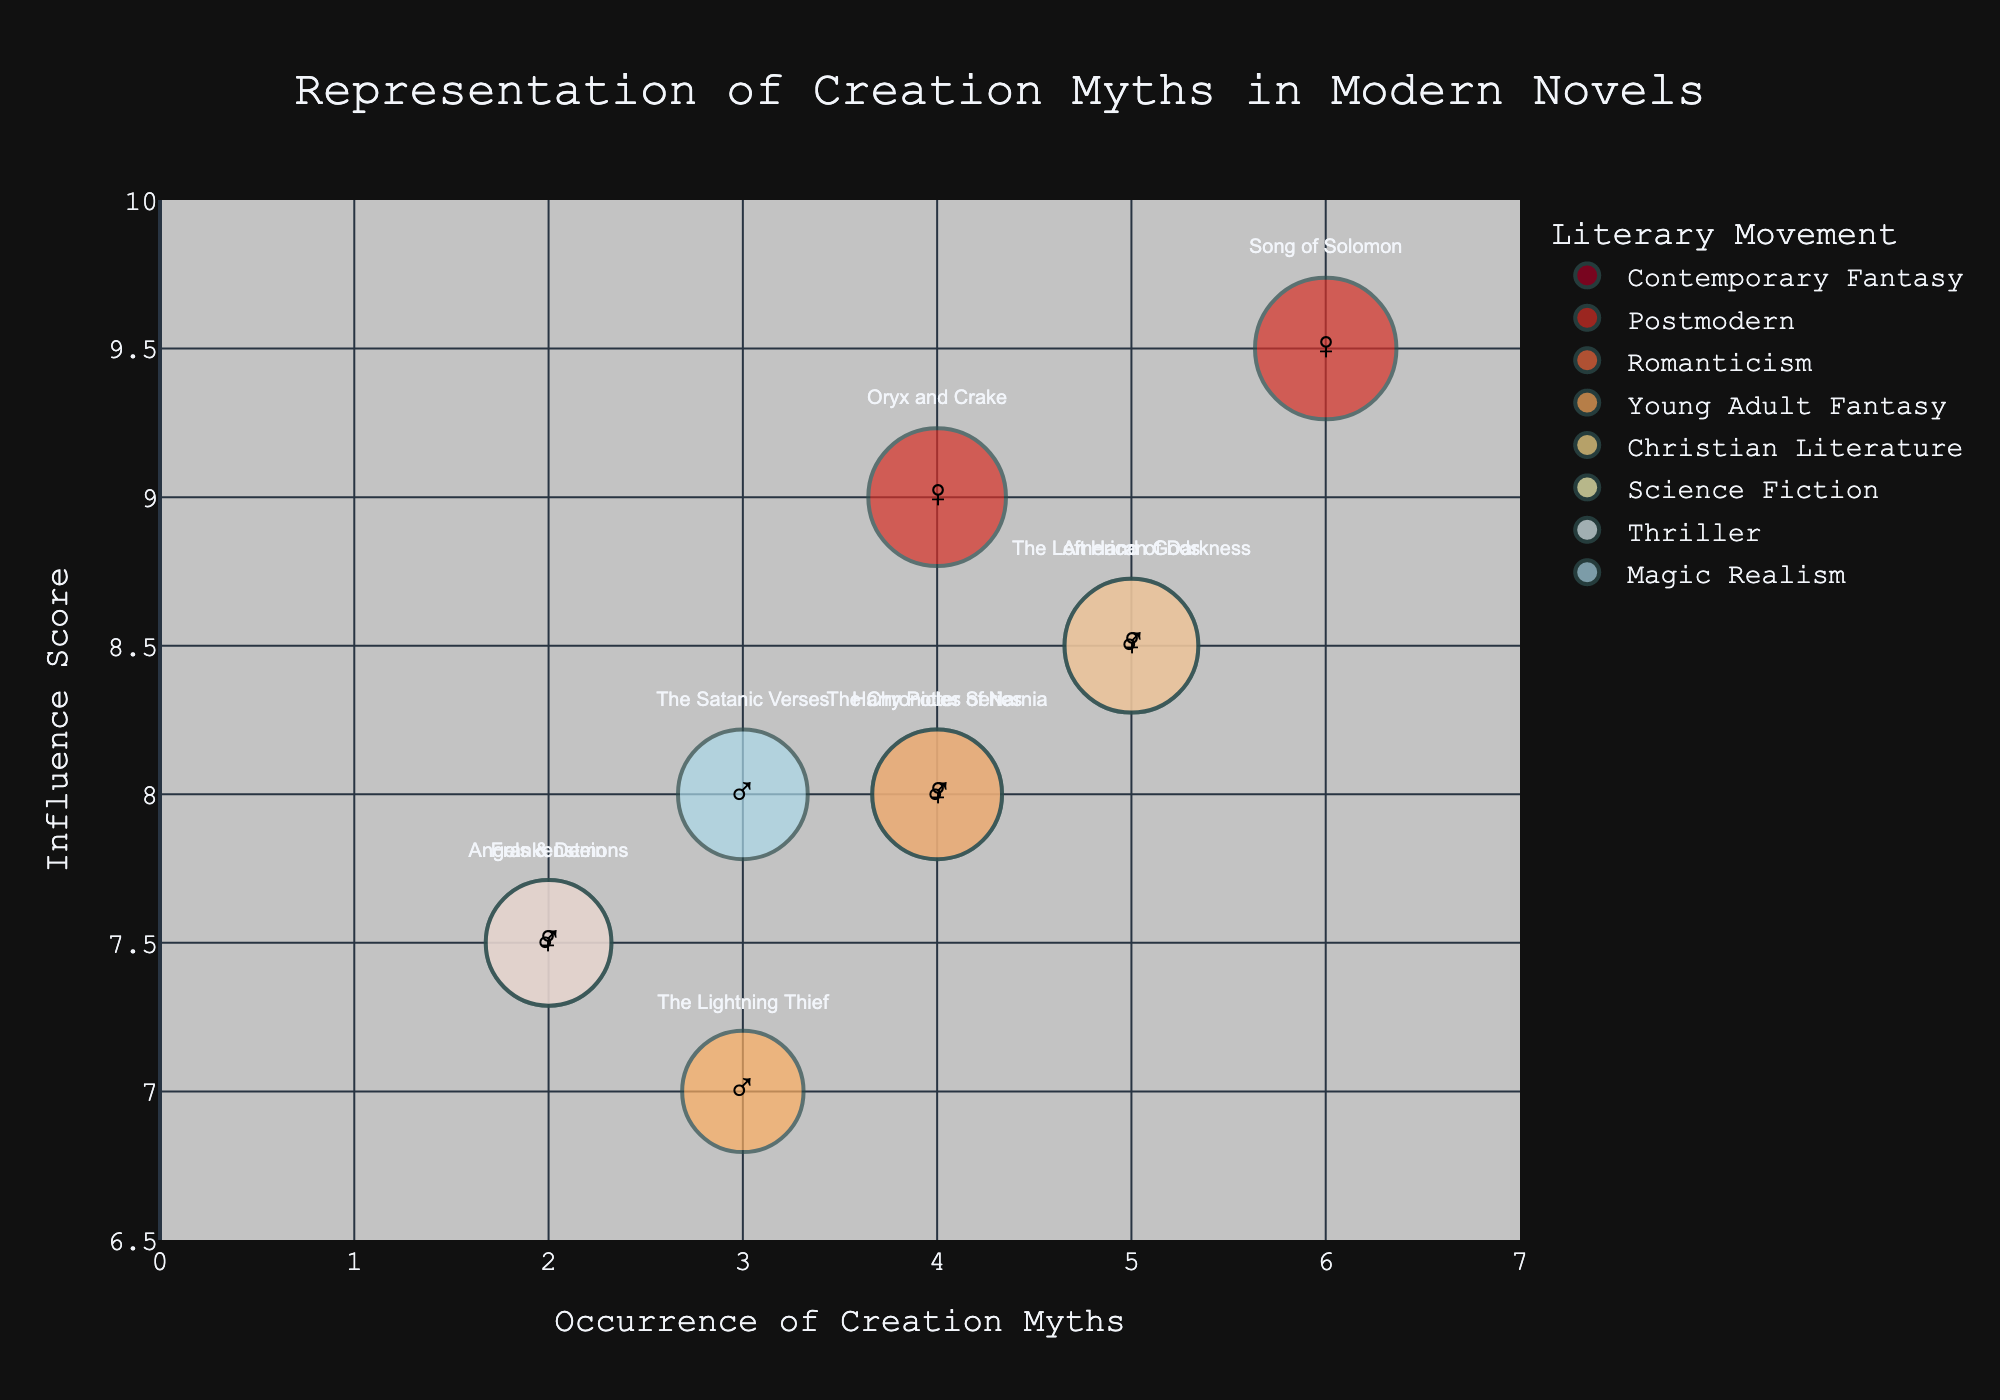What is the title of the chart? The title is prominently displayed at the top of the chart and reads "Representation of Creation Myths in Modern Novels".
Answer: Representation of Creation Myths in Modern Novels How many authors are represented in the chart? By counting the unique data points (bubbles) on the chart, each corresponding to an author, we find there are 10 authors represented.
Answer: 10 Which author has the highest Influence Score and what is it? By looking at the y-axis where Influence Score is plotted, we observe Toni Morrison’s bubble is positioned highest at 9.5.
Answer: Toni Morrison, 9.5 Which Literary Movement has the most occurrences of creation myths? By looking at the x-axis and comparing the bubbles' horizontal positions (Occurrence of Creation Myths), the Postmodern movement has Toni Morrison with 6 and Margaret Atwood with 4, totaling 10 occurrences, which is the highest.
Answer: Postmodern What is the Occurrence of Creation Myths for "The Chronicles of Narnia"? By hovering over or finding the bubble labeled "The Chronicles of Narnia" by C.S. Lewis, we see its position on the x-axis is at 4.
Answer: 4 Who is the male author in the Magic Realism movement and what are his Occurrence of Creation Myths and Influence Score? By identifying the male symbol (♂) and the Magic Realism color, Salman Rushdie is seen with 3 Occurrence of Creation Myths and an Influence Score of 8.0.
Answer: Salman Rushdie, 3, 8.0 What is the average Influence Score of the authors in Contemporary Fantasy movement? The Contemporary Fantasy authors are Neil Gaiman (8.5) and J.K. Rowling (8.0). Calculating the average: (8.5 + 8.0) / 2 = 8.25.
Answer: 8.25 Which movement has the largest bubble, indicating the highest Influence Score? The bubble size represents the Influence Score. By visually identifying the largest bubble, it is associated with the Postmodern movement (Toni Morrison).
Answer: Postmodern Compare the Influence Scores of "Frankenstein" and "The Lightning Thief". Which is higher and by how much? Mary Shelley’s "Frankenstein" has an Influence Score of 7.5, and Rick Riordan’s "The Lightning Thief" has 7.0. The difference is 7.5 - 7.0 = 0.5.
Answer: "Frankenstein" by 0.5 